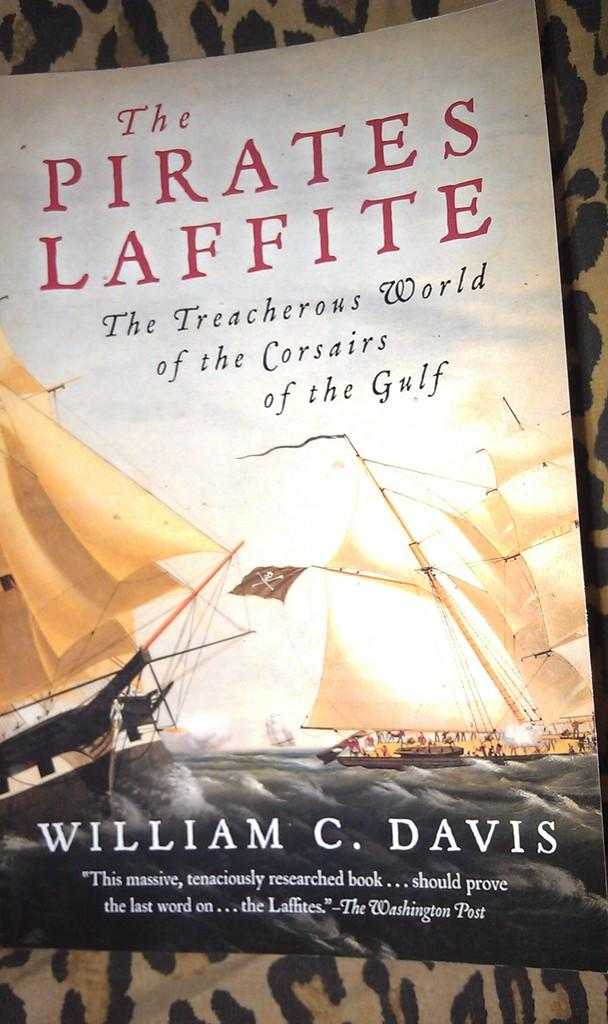<image>
Write a terse but informative summary of the picture. A book with ships on it called The Pirates Laffite. 